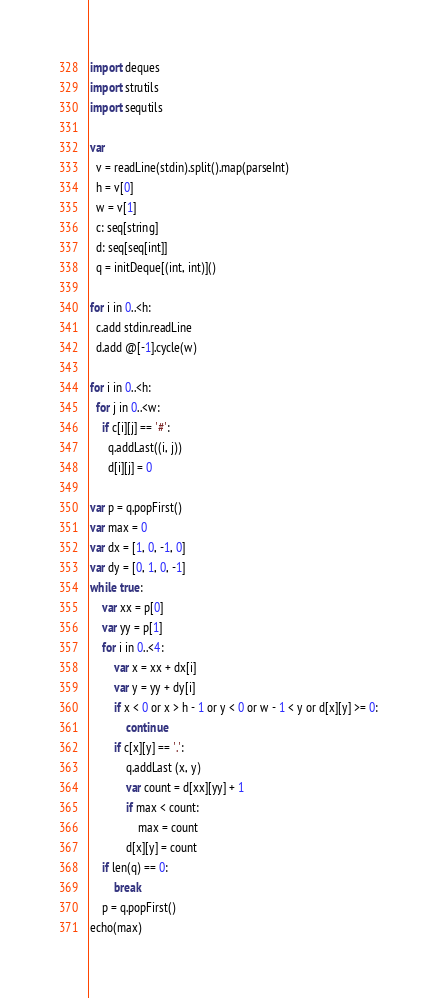Convert code to text. <code><loc_0><loc_0><loc_500><loc_500><_Nim_>import deques
import strutils
import sequtils

var
  v = readLine(stdin).split().map(parseInt)
  h = v[0]
  w = v[1]
  c: seq[string]
  d: seq[seq[int]]
  q = initDeque[(int, int)]()

for i in 0..<h:
  c.add stdin.readLine
  d.add @[-1].cycle(w)

for i in 0..<h:
  for j in 0..<w:
    if c[i][j] == '#':
      q.addLast((i, j))
      d[i][j] = 0

var p = q.popFirst()
var max = 0
var dx = [1, 0, -1, 0]
var dy = [0, 1, 0, -1]
while true:
    var xx = p[0]
    var yy = p[1]
    for i in 0..<4:
        var x = xx + dx[i]
        var y = yy + dy[i]
        if x < 0 or x > h - 1 or y < 0 or w - 1 < y or d[x][y] >= 0:
            continue
        if c[x][y] == '.':
            q.addLast (x, y)
            var count = d[xx][yy] + 1
            if max < count:
                max = count
            d[x][y] = count
    if len(q) == 0:
        break
    p = q.popFirst()
echo(max)
</code> 